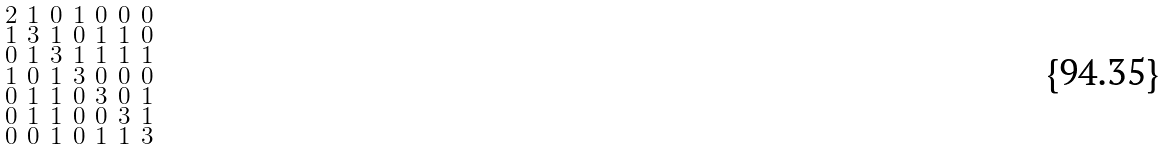<formula> <loc_0><loc_0><loc_500><loc_500>\begin{smallmatrix} 2 & 1 & 0 & 1 & 0 & 0 & 0 \\ 1 & 3 & 1 & 0 & 1 & 1 & 0 \\ 0 & 1 & 3 & 1 & 1 & 1 & 1 \\ 1 & 0 & 1 & 3 & 0 & 0 & 0 \\ 0 & 1 & 1 & 0 & 3 & 0 & 1 \\ 0 & 1 & 1 & 0 & 0 & 3 & 1 \\ 0 & 0 & 1 & 0 & 1 & 1 & 3 \end{smallmatrix}</formula> 